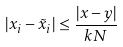Convert formula to latex. <formula><loc_0><loc_0><loc_500><loc_500>| x _ { i } - \tilde { x } _ { i } | \leq \frac { | x - y | } { k N }</formula> 